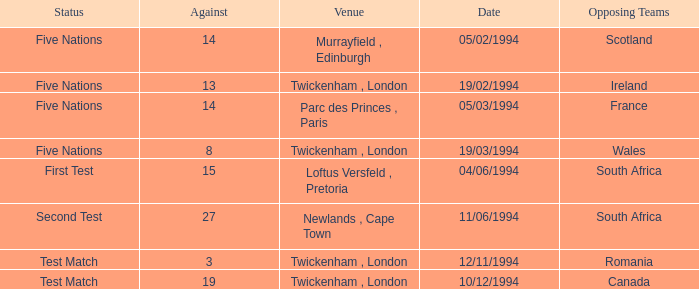Which venue has more than 19 against? Newlands , Cape Town. 